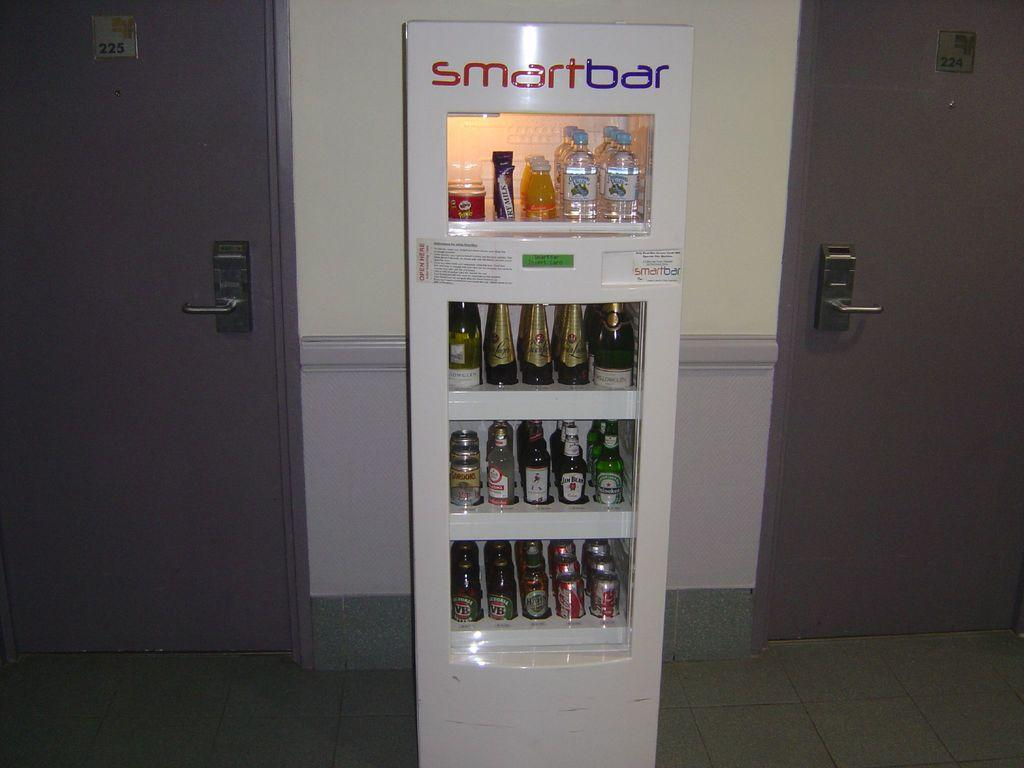<image>
Present a compact description of the photo's key features. A Smart Bar vending machine sits between two purple doors that sells thinks like Coca Cola and Heineken. 